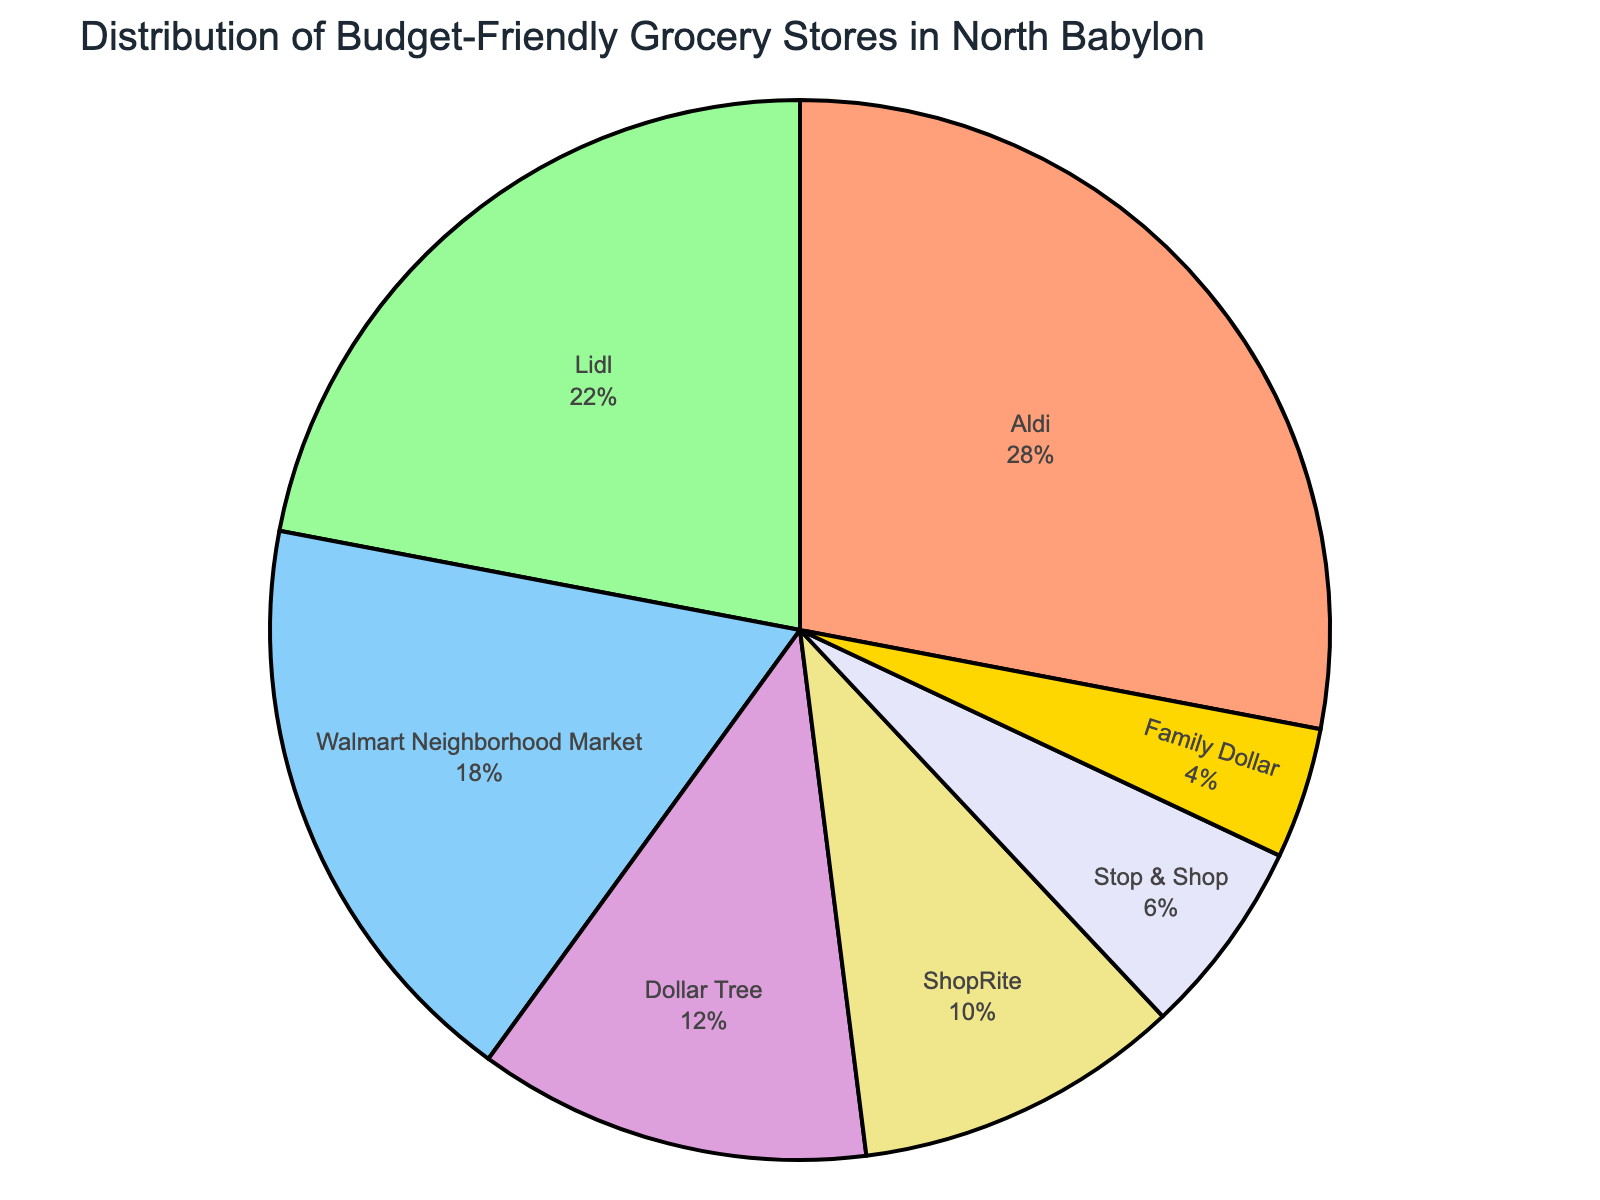What's the store with the smallest percentage in the distribution? Identify the store with the smallest slice in the pie chart and read the label associated with it. According to the chart, Family Dollar represents the smallest percentage.
Answer: Family Dollar Which two stores combined make up exactly 50% of the distribution? Identify the stores with the percentages that sum to 50%. Aldi has 28%, and Lidl has 22%, so together they make up 50%.
Answer: Aldi and Lidl What is the percentage difference between the stores with the highest and lowest percentages? Subtract the lowest percentage from the highest percentage. Aldi has the highest with 28%, and Family Dollar has the lowest with 4%. So the difference is 28% - 4% = 24%.
Answer: 24% How do the combined percentages of ShopRite and Stop & Shop compare to Aldi’s percentage? Add the percentages of ShopRite (10%) and Stop & Shop (6%) and compare the sum to Aldi’s percentage. 10% + 6% = 16%, which is less than Aldi’s 28%.
Answer: Less than What percentage do Walmart Neighborhood Market and Dollar Tree together account for? Add the percentages of Walmart Neighborhood Market (18%) and Dollar Tree (12%). The sum is 18% + 12% = 30%.
Answer: 30% What are the stores represented by the green and blue sections respectively? Refer to the colors in the pie chart. Green represents Lidl, and blue represents Walmart Neighborhood Market.
Answer: Lidl and Walmart Neighborhood Market If you ignore the two stores with the smallest percentages, what is the combined percentage of the remaining stores? Exclude Family Dollar (4%) and Stop & Shop (6%) and sum the rest. The percentages for the remaining stores are 28% (Aldi) + 22% (Lidl) + 18% (Walmart Neighborhood Market) + 12% (Dollar Tree) + 10% (ShopRite). So the combined percentage is 28% + 22% + 18% + 12% + 10% = 90%.
Answer: 90% Which store has a percentage close to a quarter of the entire distribution? Identify the store with a percentage close to one-fourth (25%). Aldi has 28%, which is close to 25%.
Answer: Aldi How many stores together make up more than half of the total distribution? Determine the combinations of stores whose percentages sum to more than 50%. Aldi (28%) + Lidl (22%) = 50%, but we need more than half. Adding Walmart Neighborhood Market (18%) gives 28% + 22% + 18% = 68%, so a combination of three stores achieves this.
Answer: Three What is the combined percentage of stores represented by warm colors (like shades of orange or yellow)? Identify the stores with warm colors in the chart. Aldi (orange, 28%) and ShopRite (yellow, 10%). Combine their percentages: 28% + 10% = 38%.
Answer: 38% 